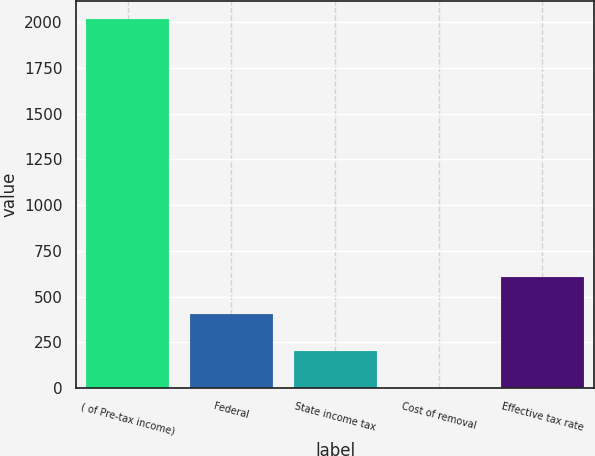Convert chart to OTSL. <chart><loc_0><loc_0><loc_500><loc_500><bar_chart><fcel>( of Pre-tax income)<fcel>Federal<fcel>State income tax<fcel>Cost of removal<fcel>Effective tax rate<nl><fcel>2017<fcel>404.2<fcel>202.6<fcel>1<fcel>605.8<nl></chart> 